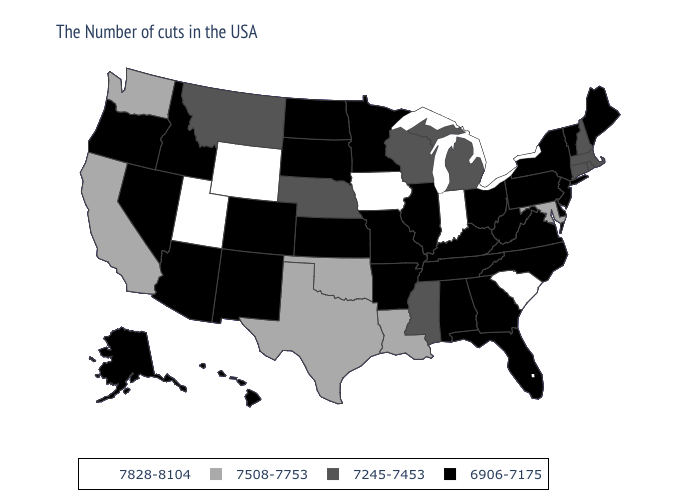Which states hav the highest value in the Northeast?
Short answer required. Massachusetts, Rhode Island, New Hampshire, Connecticut. Which states hav the highest value in the South?
Quick response, please. South Carolina. Does Iowa have the highest value in the USA?
Concise answer only. Yes. Does North Carolina have the highest value in the USA?
Quick response, please. No. Does Texas have the lowest value in the USA?
Quick response, please. No. What is the highest value in the West ?
Write a very short answer. 7828-8104. Among the states that border Georgia , which have the lowest value?
Keep it brief. North Carolina, Florida, Alabama, Tennessee. Does the first symbol in the legend represent the smallest category?
Answer briefly. No. Does Kentucky have a higher value than Colorado?
Give a very brief answer. No. Name the states that have a value in the range 7828-8104?
Write a very short answer. South Carolina, Indiana, Iowa, Wyoming, Utah. Does Massachusetts have the lowest value in the Northeast?
Quick response, please. No. Name the states that have a value in the range 7508-7753?
Keep it brief. Maryland, Louisiana, Oklahoma, Texas, California, Washington. Name the states that have a value in the range 6906-7175?
Write a very short answer. Maine, Vermont, New York, New Jersey, Delaware, Pennsylvania, Virginia, North Carolina, West Virginia, Ohio, Florida, Georgia, Kentucky, Alabama, Tennessee, Illinois, Missouri, Arkansas, Minnesota, Kansas, South Dakota, North Dakota, Colorado, New Mexico, Arizona, Idaho, Nevada, Oregon, Alaska, Hawaii. Among the states that border Illinois , does Missouri have the lowest value?
Quick response, please. Yes. 